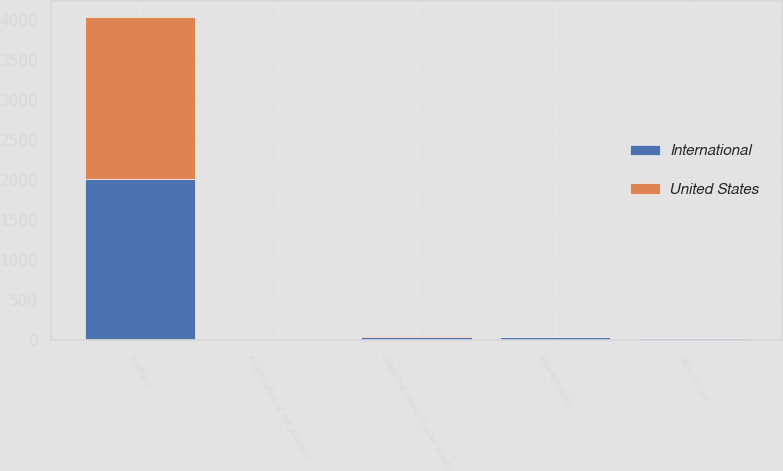Convert chart. <chart><loc_0><loc_0><loc_500><loc_500><stacked_bar_chart><ecel><fcel>(millions)<fcel>Service cost<fcel>Interest costs<fcel>Expected return on plan assets<fcel>Amortization of net actuarial<nl><fcel>International<fcel>2016<fcel>21.5<fcel>33.3<fcel>40.8<fcel>12.6<nl><fcel>United States<fcel>2016<fcel>7.1<fcel>11.3<fcel>16.2<fcel>4.1<nl></chart> 